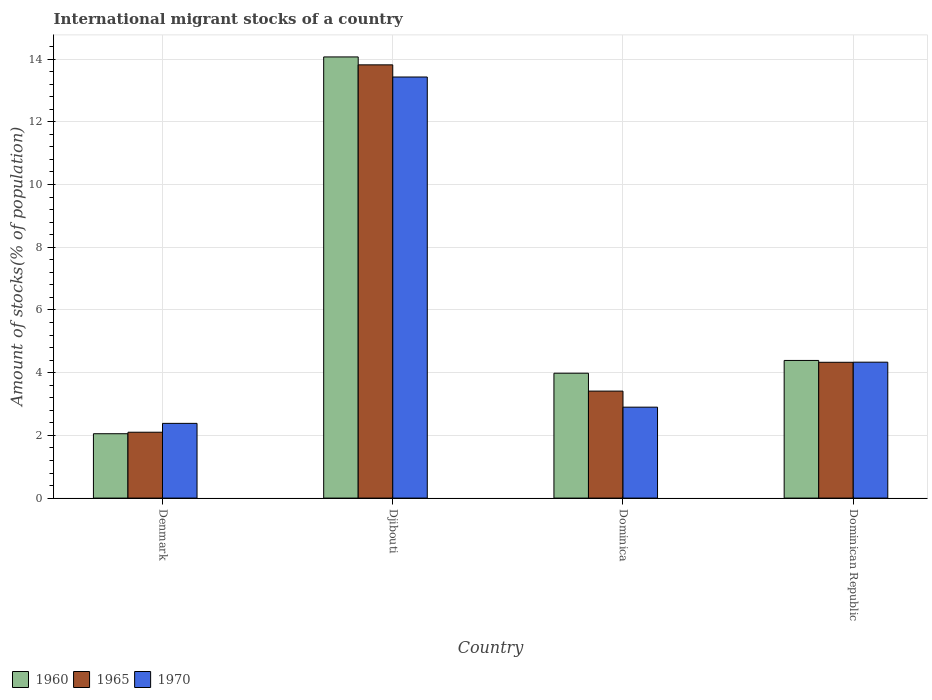Are the number of bars per tick equal to the number of legend labels?
Ensure brevity in your answer.  Yes. How many bars are there on the 1st tick from the left?
Offer a very short reply. 3. How many bars are there on the 2nd tick from the right?
Your answer should be very brief. 3. In how many cases, is the number of bars for a given country not equal to the number of legend labels?
Your response must be concise. 0. What is the amount of stocks in in 1970 in Dominican Republic?
Offer a very short reply. 4.33. Across all countries, what is the maximum amount of stocks in in 1960?
Offer a terse response. 14.07. Across all countries, what is the minimum amount of stocks in in 1960?
Your response must be concise. 2.05. In which country was the amount of stocks in in 1965 maximum?
Provide a succinct answer. Djibouti. In which country was the amount of stocks in in 1965 minimum?
Your response must be concise. Denmark. What is the total amount of stocks in in 1965 in the graph?
Make the answer very short. 23.66. What is the difference between the amount of stocks in in 1960 in Denmark and that in Dominican Republic?
Your answer should be compact. -2.34. What is the difference between the amount of stocks in in 1960 in Denmark and the amount of stocks in in 1965 in Dominica?
Your answer should be very brief. -1.36. What is the average amount of stocks in in 1960 per country?
Provide a short and direct response. 6.12. What is the difference between the amount of stocks in of/in 1970 and amount of stocks in of/in 1960 in Denmark?
Keep it short and to the point. 0.33. In how many countries, is the amount of stocks in in 1970 greater than 14 %?
Offer a terse response. 0. What is the ratio of the amount of stocks in in 1970 in Denmark to that in Dominican Republic?
Your answer should be compact. 0.55. Is the amount of stocks in in 1970 in Djibouti less than that in Dominican Republic?
Your answer should be very brief. No. What is the difference between the highest and the second highest amount of stocks in in 1970?
Offer a very short reply. -1.43. What is the difference between the highest and the lowest amount of stocks in in 1970?
Your answer should be very brief. 11.05. In how many countries, is the amount of stocks in in 1960 greater than the average amount of stocks in in 1960 taken over all countries?
Offer a terse response. 1. What does the 2nd bar from the left in Dominican Republic represents?
Make the answer very short. 1965. What does the 3rd bar from the right in Djibouti represents?
Provide a short and direct response. 1960. Is it the case that in every country, the sum of the amount of stocks in in 1965 and amount of stocks in in 1970 is greater than the amount of stocks in in 1960?
Offer a very short reply. Yes. How many bars are there?
Your response must be concise. 12. Are all the bars in the graph horizontal?
Your response must be concise. No. How many countries are there in the graph?
Offer a terse response. 4. What is the difference between two consecutive major ticks on the Y-axis?
Your response must be concise. 2. How are the legend labels stacked?
Your answer should be very brief. Horizontal. What is the title of the graph?
Keep it short and to the point. International migrant stocks of a country. What is the label or title of the X-axis?
Make the answer very short. Country. What is the label or title of the Y-axis?
Offer a very short reply. Amount of stocks(% of population). What is the Amount of stocks(% of population) in 1960 in Denmark?
Your answer should be compact. 2.05. What is the Amount of stocks(% of population) of 1965 in Denmark?
Offer a terse response. 2.1. What is the Amount of stocks(% of population) of 1970 in Denmark?
Offer a very short reply. 2.38. What is the Amount of stocks(% of population) of 1960 in Djibouti?
Keep it short and to the point. 14.07. What is the Amount of stocks(% of population) of 1965 in Djibouti?
Offer a very short reply. 13.82. What is the Amount of stocks(% of population) of 1970 in Djibouti?
Offer a terse response. 13.43. What is the Amount of stocks(% of population) of 1960 in Dominica?
Your answer should be very brief. 3.98. What is the Amount of stocks(% of population) in 1965 in Dominica?
Your answer should be very brief. 3.41. What is the Amount of stocks(% of population) of 1970 in Dominica?
Provide a short and direct response. 2.9. What is the Amount of stocks(% of population) of 1960 in Dominican Republic?
Give a very brief answer. 4.39. What is the Amount of stocks(% of population) of 1965 in Dominican Republic?
Give a very brief answer. 4.33. What is the Amount of stocks(% of population) in 1970 in Dominican Republic?
Offer a very short reply. 4.33. Across all countries, what is the maximum Amount of stocks(% of population) of 1960?
Offer a terse response. 14.07. Across all countries, what is the maximum Amount of stocks(% of population) of 1965?
Offer a terse response. 13.82. Across all countries, what is the maximum Amount of stocks(% of population) in 1970?
Give a very brief answer. 13.43. Across all countries, what is the minimum Amount of stocks(% of population) of 1960?
Offer a very short reply. 2.05. Across all countries, what is the minimum Amount of stocks(% of population) in 1965?
Provide a succinct answer. 2.1. Across all countries, what is the minimum Amount of stocks(% of population) in 1970?
Make the answer very short. 2.38. What is the total Amount of stocks(% of population) of 1960 in the graph?
Offer a very short reply. 24.49. What is the total Amount of stocks(% of population) in 1965 in the graph?
Keep it short and to the point. 23.66. What is the total Amount of stocks(% of population) in 1970 in the graph?
Your response must be concise. 23.04. What is the difference between the Amount of stocks(% of population) in 1960 in Denmark and that in Djibouti?
Your answer should be very brief. -12.02. What is the difference between the Amount of stocks(% of population) of 1965 in Denmark and that in Djibouti?
Offer a terse response. -11.72. What is the difference between the Amount of stocks(% of population) in 1970 in Denmark and that in Djibouti?
Provide a succinct answer. -11.05. What is the difference between the Amount of stocks(% of population) in 1960 in Denmark and that in Dominica?
Your answer should be very brief. -1.93. What is the difference between the Amount of stocks(% of population) of 1965 in Denmark and that in Dominica?
Make the answer very short. -1.31. What is the difference between the Amount of stocks(% of population) in 1970 in Denmark and that in Dominica?
Offer a terse response. -0.52. What is the difference between the Amount of stocks(% of population) of 1960 in Denmark and that in Dominican Republic?
Your response must be concise. -2.34. What is the difference between the Amount of stocks(% of population) in 1965 in Denmark and that in Dominican Republic?
Offer a terse response. -2.23. What is the difference between the Amount of stocks(% of population) of 1970 in Denmark and that in Dominican Republic?
Ensure brevity in your answer.  -1.95. What is the difference between the Amount of stocks(% of population) in 1960 in Djibouti and that in Dominica?
Offer a terse response. 10.09. What is the difference between the Amount of stocks(% of population) in 1965 in Djibouti and that in Dominica?
Ensure brevity in your answer.  10.4. What is the difference between the Amount of stocks(% of population) of 1970 in Djibouti and that in Dominica?
Your answer should be very brief. 10.53. What is the difference between the Amount of stocks(% of population) in 1960 in Djibouti and that in Dominican Republic?
Your answer should be very brief. 9.68. What is the difference between the Amount of stocks(% of population) of 1965 in Djibouti and that in Dominican Republic?
Offer a very short reply. 9.49. What is the difference between the Amount of stocks(% of population) in 1970 in Djibouti and that in Dominican Republic?
Ensure brevity in your answer.  9.09. What is the difference between the Amount of stocks(% of population) of 1960 in Dominica and that in Dominican Republic?
Your answer should be very brief. -0.41. What is the difference between the Amount of stocks(% of population) of 1965 in Dominica and that in Dominican Republic?
Keep it short and to the point. -0.92. What is the difference between the Amount of stocks(% of population) of 1970 in Dominica and that in Dominican Republic?
Your response must be concise. -1.43. What is the difference between the Amount of stocks(% of population) in 1960 in Denmark and the Amount of stocks(% of population) in 1965 in Djibouti?
Your answer should be compact. -11.76. What is the difference between the Amount of stocks(% of population) in 1960 in Denmark and the Amount of stocks(% of population) in 1970 in Djibouti?
Provide a succinct answer. -11.38. What is the difference between the Amount of stocks(% of population) in 1965 in Denmark and the Amount of stocks(% of population) in 1970 in Djibouti?
Your answer should be compact. -11.33. What is the difference between the Amount of stocks(% of population) in 1960 in Denmark and the Amount of stocks(% of population) in 1965 in Dominica?
Offer a very short reply. -1.36. What is the difference between the Amount of stocks(% of population) in 1960 in Denmark and the Amount of stocks(% of population) in 1970 in Dominica?
Offer a terse response. -0.85. What is the difference between the Amount of stocks(% of population) of 1965 in Denmark and the Amount of stocks(% of population) of 1970 in Dominica?
Provide a short and direct response. -0.8. What is the difference between the Amount of stocks(% of population) in 1960 in Denmark and the Amount of stocks(% of population) in 1965 in Dominican Republic?
Offer a very short reply. -2.28. What is the difference between the Amount of stocks(% of population) in 1960 in Denmark and the Amount of stocks(% of population) in 1970 in Dominican Republic?
Your answer should be very brief. -2.28. What is the difference between the Amount of stocks(% of population) of 1965 in Denmark and the Amount of stocks(% of population) of 1970 in Dominican Republic?
Provide a short and direct response. -2.23. What is the difference between the Amount of stocks(% of population) of 1960 in Djibouti and the Amount of stocks(% of population) of 1965 in Dominica?
Provide a succinct answer. 10.66. What is the difference between the Amount of stocks(% of population) in 1960 in Djibouti and the Amount of stocks(% of population) in 1970 in Dominica?
Make the answer very short. 11.17. What is the difference between the Amount of stocks(% of population) in 1965 in Djibouti and the Amount of stocks(% of population) in 1970 in Dominica?
Your answer should be compact. 10.92. What is the difference between the Amount of stocks(% of population) of 1960 in Djibouti and the Amount of stocks(% of population) of 1965 in Dominican Republic?
Provide a short and direct response. 9.74. What is the difference between the Amount of stocks(% of population) in 1960 in Djibouti and the Amount of stocks(% of population) in 1970 in Dominican Republic?
Offer a very short reply. 9.73. What is the difference between the Amount of stocks(% of population) in 1965 in Djibouti and the Amount of stocks(% of population) in 1970 in Dominican Republic?
Make the answer very short. 9.48. What is the difference between the Amount of stocks(% of population) of 1960 in Dominica and the Amount of stocks(% of population) of 1965 in Dominican Republic?
Your answer should be compact. -0.35. What is the difference between the Amount of stocks(% of population) in 1960 in Dominica and the Amount of stocks(% of population) in 1970 in Dominican Republic?
Ensure brevity in your answer.  -0.35. What is the difference between the Amount of stocks(% of population) in 1965 in Dominica and the Amount of stocks(% of population) in 1970 in Dominican Republic?
Offer a terse response. -0.92. What is the average Amount of stocks(% of population) of 1960 per country?
Keep it short and to the point. 6.12. What is the average Amount of stocks(% of population) in 1965 per country?
Offer a terse response. 5.91. What is the average Amount of stocks(% of population) in 1970 per country?
Your answer should be very brief. 5.76. What is the difference between the Amount of stocks(% of population) in 1960 and Amount of stocks(% of population) in 1965 in Denmark?
Keep it short and to the point. -0.05. What is the difference between the Amount of stocks(% of population) in 1960 and Amount of stocks(% of population) in 1970 in Denmark?
Your answer should be compact. -0.33. What is the difference between the Amount of stocks(% of population) of 1965 and Amount of stocks(% of population) of 1970 in Denmark?
Make the answer very short. -0.28. What is the difference between the Amount of stocks(% of population) of 1960 and Amount of stocks(% of population) of 1965 in Djibouti?
Your answer should be compact. 0.25. What is the difference between the Amount of stocks(% of population) of 1960 and Amount of stocks(% of population) of 1970 in Djibouti?
Provide a succinct answer. 0.64. What is the difference between the Amount of stocks(% of population) of 1965 and Amount of stocks(% of population) of 1970 in Djibouti?
Provide a succinct answer. 0.39. What is the difference between the Amount of stocks(% of population) in 1960 and Amount of stocks(% of population) in 1965 in Dominica?
Give a very brief answer. 0.57. What is the difference between the Amount of stocks(% of population) of 1960 and Amount of stocks(% of population) of 1970 in Dominica?
Provide a succinct answer. 1.08. What is the difference between the Amount of stocks(% of population) of 1965 and Amount of stocks(% of population) of 1970 in Dominica?
Your response must be concise. 0.51. What is the difference between the Amount of stocks(% of population) in 1960 and Amount of stocks(% of population) in 1965 in Dominican Republic?
Your answer should be very brief. 0.06. What is the difference between the Amount of stocks(% of population) of 1960 and Amount of stocks(% of population) of 1970 in Dominican Republic?
Offer a terse response. 0.06. What is the difference between the Amount of stocks(% of population) in 1965 and Amount of stocks(% of population) in 1970 in Dominican Republic?
Offer a terse response. -0. What is the ratio of the Amount of stocks(% of population) of 1960 in Denmark to that in Djibouti?
Make the answer very short. 0.15. What is the ratio of the Amount of stocks(% of population) in 1965 in Denmark to that in Djibouti?
Offer a terse response. 0.15. What is the ratio of the Amount of stocks(% of population) in 1970 in Denmark to that in Djibouti?
Offer a very short reply. 0.18. What is the ratio of the Amount of stocks(% of population) in 1960 in Denmark to that in Dominica?
Offer a terse response. 0.52. What is the ratio of the Amount of stocks(% of population) of 1965 in Denmark to that in Dominica?
Offer a terse response. 0.62. What is the ratio of the Amount of stocks(% of population) in 1970 in Denmark to that in Dominica?
Give a very brief answer. 0.82. What is the ratio of the Amount of stocks(% of population) of 1960 in Denmark to that in Dominican Republic?
Make the answer very short. 0.47. What is the ratio of the Amount of stocks(% of population) in 1965 in Denmark to that in Dominican Republic?
Your answer should be compact. 0.48. What is the ratio of the Amount of stocks(% of population) in 1970 in Denmark to that in Dominican Republic?
Keep it short and to the point. 0.55. What is the ratio of the Amount of stocks(% of population) in 1960 in Djibouti to that in Dominica?
Keep it short and to the point. 3.53. What is the ratio of the Amount of stocks(% of population) of 1965 in Djibouti to that in Dominica?
Your answer should be compact. 4.05. What is the ratio of the Amount of stocks(% of population) of 1970 in Djibouti to that in Dominica?
Your response must be concise. 4.63. What is the ratio of the Amount of stocks(% of population) of 1960 in Djibouti to that in Dominican Republic?
Give a very brief answer. 3.21. What is the ratio of the Amount of stocks(% of population) in 1965 in Djibouti to that in Dominican Republic?
Offer a terse response. 3.19. What is the ratio of the Amount of stocks(% of population) of 1970 in Djibouti to that in Dominican Republic?
Provide a short and direct response. 3.1. What is the ratio of the Amount of stocks(% of population) of 1960 in Dominica to that in Dominican Republic?
Offer a terse response. 0.91. What is the ratio of the Amount of stocks(% of population) of 1965 in Dominica to that in Dominican Republic?
Ensure brevity in your answer.  0.79. What is the ratio of the Amount of stocks(% of population) of 1970 in Dominica to that in Dominican Republic?
Offer a terse response. 0.67. What is the difference between the highest and the second highest Amount of stocks(% of population) in 1960?
Provide a succinct answer. 9.68. What is the difference between the highest and the second highest Amount of stocks(% of population) of 1965?
Make the answer very short. 9.49. What is the difference between the highest and the second highest Amount of stocks(% of population) in 1970?
Your answer should be very brief. 9.09. What is the difference between the highest and the lowest Amount of stocks(% of population) in 1960?
Ensure brevity in your answer.  12.02. What is the difference between the highest and the lowest Amount of stocks(% of population) of 1965?
Your response must be concise. 11.72. What is the difference between the highest and the lowest Amount of stocks(% of population) in 1970?
Your answer should be very brief. 11.05. 